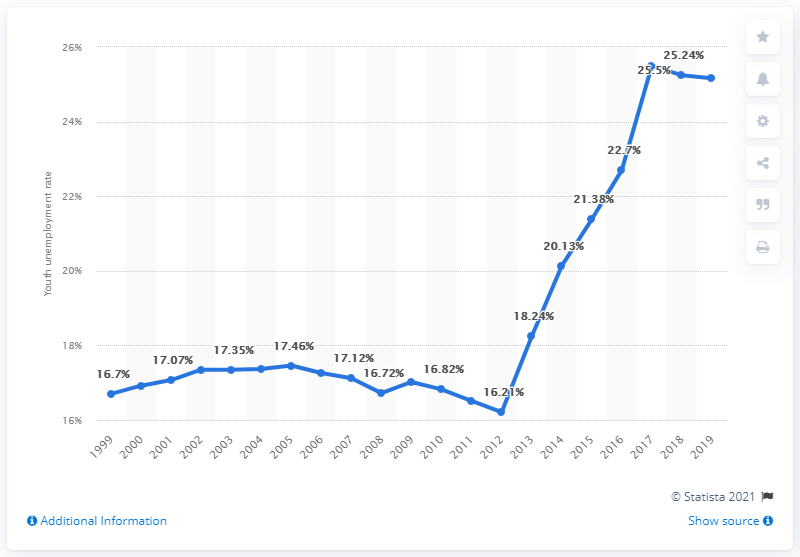Draw attention to some important aspects in this diagram. In 2019, the youth unemployment rate in Iraq was 25.16%. 